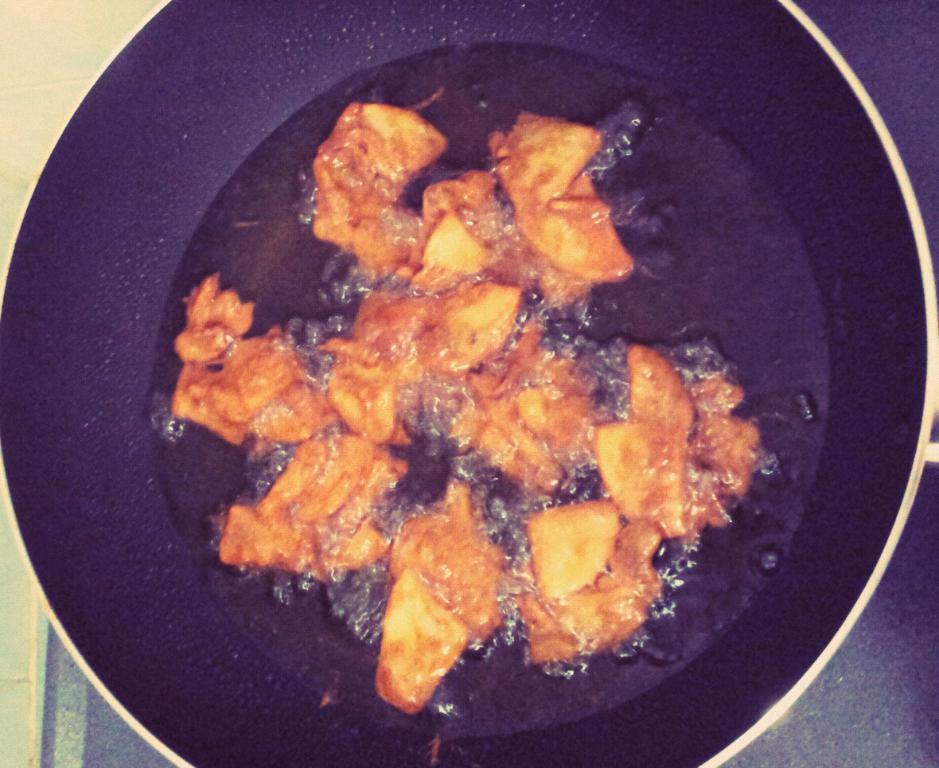Can you describe this image briefly? In this image I can see a black bowl,oil and food inside. Food is in brown color. 